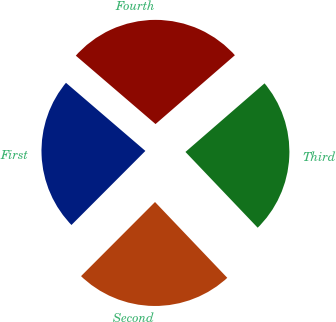Convert chart. <chart><loc_0><loc_0><loc_500><loc_500><pie_chart><fcel>First<fcel>Second<fcel>Third<fcel>Fourth<nl><fcel>23.8%<fcel>24.6%<fcel>24.25%<fcel>27.34%<nl></chart> 